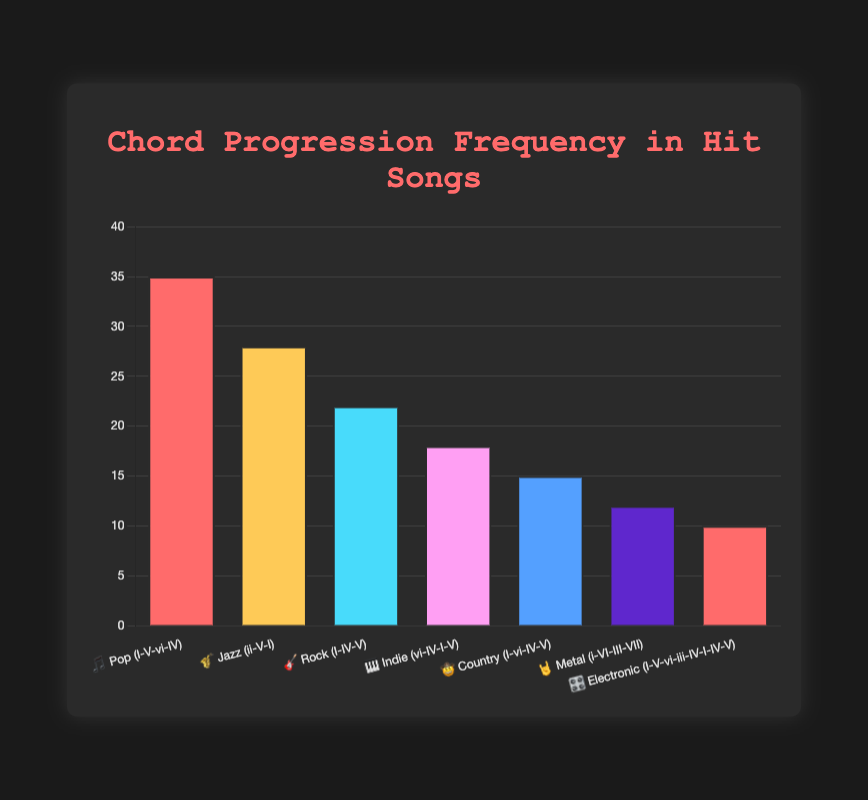What's the title of the chart? The title is displayed at the top of the chart in large, highlighted text.
Answer: Chord Progression Frequency in Hit Songs How many genres are represented in the chart? Count the number of different genres listed along the x-axis of the chart.
Answer: 7 Which genre has the highest frequency of the chord progression? Locate the bar with the tallest height on the chart, as it represents the highest frequency.
Answer: Pop Which genre and chord progression combination corresponds to the frequency of 12? Find the bar that corresponds to the frequency level of 12 on the y-axis and check its associated label on the x-axis.
Answer: Metal (i-VI-III-VII) What is the average frequency of the chord progressions across all genres? Sum all the frequencies and divide by the number of genres: (35 + 28 + 22 + 18 + 15 + 12 + 10) / 7 = 140 / 7 = 20
Answer: 20 Which two genres have frequencies with a difference of 10? Compare the frequencies by subtracting pairs until finding the difference of 10. Pop (35) - Jazz (25) = 10
Answer: Pop and Jazz What is the median frequency of chord progressions in this chart? List the frequencies in ascending order (10, 12, 15, 18, 22, 28, 35). The middle value is the 4th one, which is 18.
Answer: 18 What is the total frequency of chord progressions for genres with more than 20 frequency? Sum the frequencies for genres with more than 20: Pop (35) + Jazz (28) + Rock (22) = 85
Answer: 85 Which genre and chord progression has the lowest frequency and what is it? Find the shortest bar, indicating the lowest frequency, and read its label.
Answer: Electronic (I-V-vi-iii-IV-I-IV-V) What is the combined frequency of the chord progressions in the Indie, Country, and Metal genres? Add the frequencies of Indie (18), Country (15), and Metal (12): 18 + 15 + 12 = 45
Answer: 45 